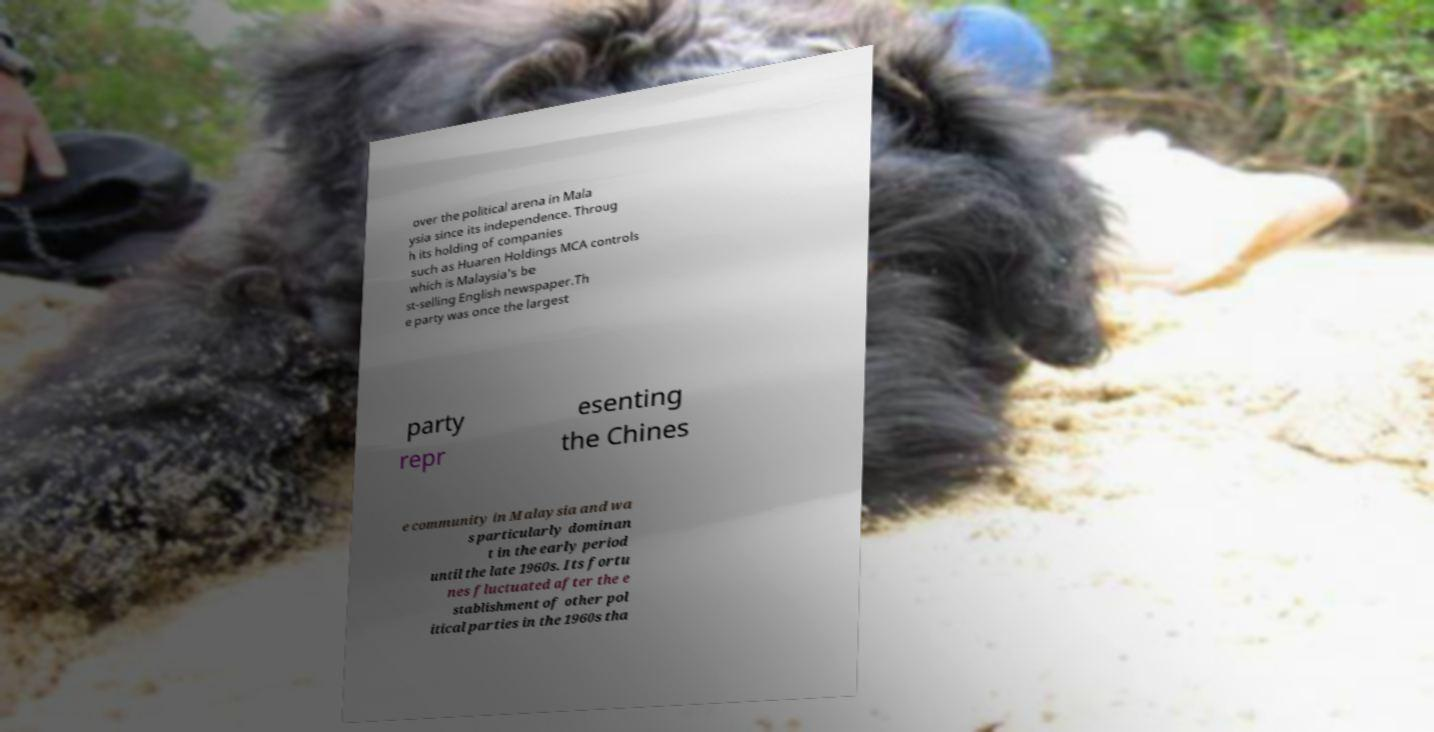There's text embedded in this image that I need extracted. Can you transcribe it verbatim? over the political arena in Mala ysia since its independence. Throug h its holding of companies such as Huaren Holdings MCA controls which is Malaysia's be st-selling English newspaper.Th e party was once the largest party repr esenting the Chines e community in Malaysia and wa s particularly dominan t in the early period until the late 1960s. Its fortu nes fluctuated after the e stablishment of other pol itical parties in the 1960s tha 